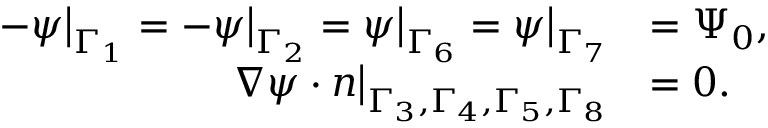Convert formula to latex. <formula><loc_0><loc_0><loc_500><loc_500>\begin{array} { r l } { - \psi \Big | _ { \Gamma _ { 1 } } = - \psi \Big | _ { \Gamma _ { 2 } } = \psi \Big | _ { \Gamma _ { 6 } } = \psi \Big | _ { \Gamma _ { 7 } } } & { = \Psi _ { 0 } , } \\ { \nabla \psi \cdot n \Big | _ { \Gamma _ { 3 } , \Gamma _ { 4 } , \Gamma _ { 5 } , \Gamma _ { 8 } } } & { = 0 . } \end{array}</formula> 